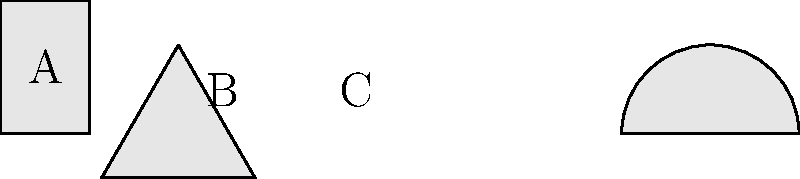As a history professor familiar with The Citadel's architectural heritage, identify which of the simplified building shapes (A, B, or C) most closely represents the prevalent architectural style found in The Citadel's historic campus buildings? To answer this question, let's analyze each building shape and compare it to The Citadel's architectural history:

1. Building A: This represents a simple rectangular structure, which is common in many architectural styles but not distinctively representative of The Citadel's primary architectural style.

2. Building B: This triangular shape is not typical of traditional academic or military architecture and does not align with The Citadel's historical buildings.

3. Building C: This shape, with its arched top, is reminiscent of the Moorish Revival style, which is the predominant architectural style at The Citadel.

The Citadel's campus, particularly its iconic Padgett-Thomas Barracks and other historic buildings, are known for their Moorish Revival architecture. This style, popular in the 19th century, is characterized by:

- Arched windows and doorways
- Decorative tilework
- Intricate patterns
- Domed or arched roofs

Building C, with its arched top, most closely represents this style. The arch is a key feature of Moorish Revival architecture, often seen in windows, doorways, and decorative elements of The Citadel's historic buildings.

The Moorish Revival style at The Citadel not only adds to the aesthetic beauty of the campus but also reflects the military college's rich history and connection to Charleston's architectural heritage. This style was chosen to evoke a sense of exotic romance and military strength, aligning with The Citadel's mission and identity.
Answer: C 